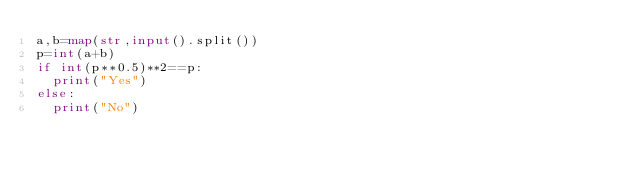<code> <loc_0><loc_0><loc_500><loc_500><_Python_>a,b=map(str,input().split())
p=int(a+b)
if int(p**0.5)**2==p:
  print("Yes")
else:
  print("No")</code> 